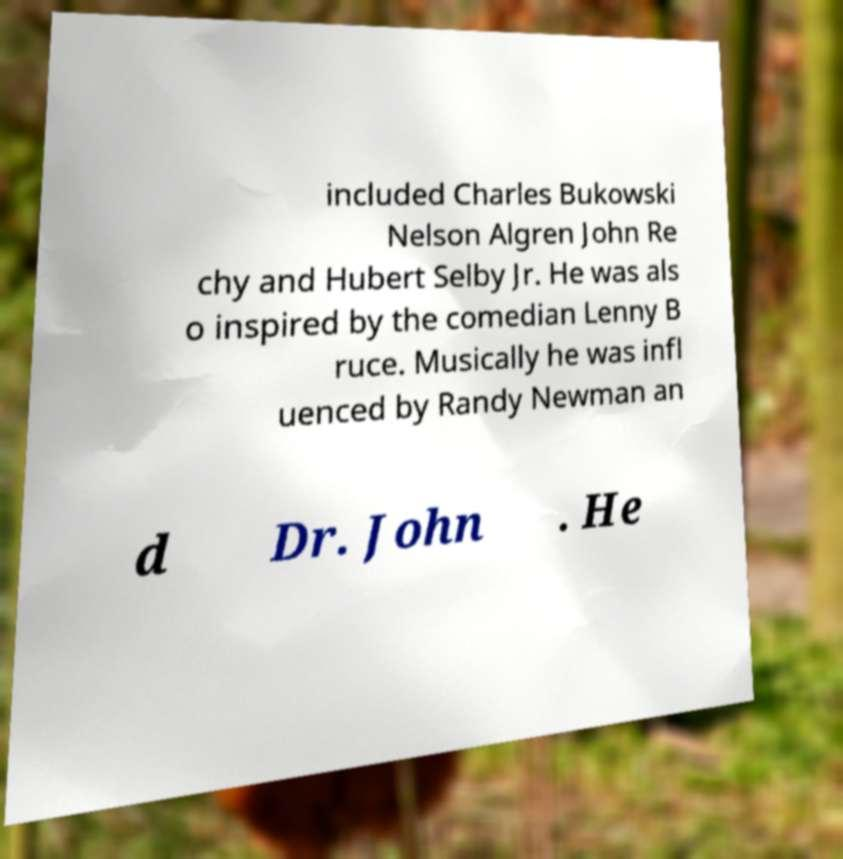Could you extract and type out the text from this image? included Charles Bukowski Nelson Algren John Re chy and Hubert Selby Jr. He was als o inspired by the comedian Lenny B ruce. Musically he was infl uenced by Randy Newman an d Dr. John . He 